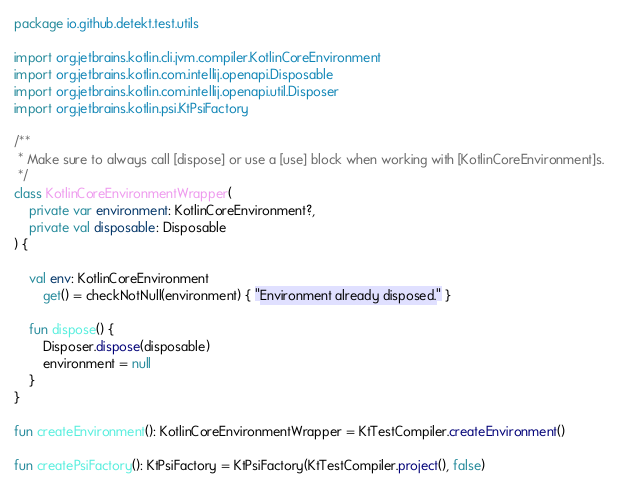Convert code to text. <code><loc_0><loc_0><loc_500><loc_500><_Kotlin_>package io.github.detekt.test.utils

import org.jetbrains.kotlin.cli.jvm.compiler.KotlinCoreEnvironment
import org.jetbrains.kotlin.com.intellij.openapi.Disposable
import org.jetbrains.kotlin.com.intellij.openapi.util.Disposer
import org.jetbrains.kotlin.psi.KtPsiFactory

/**
 * Make sure to always call [dispose] or use a [use] block when working with [KotlinCoreEnvironment]s.
 */
class KotlinCoreEnvironmentWrapper(
    private var environment: KotlinCoreEnvironment?,
    private val disposable: Disposable
) {

    val env: KotlinCoreEnvironment
        get() = checkNotNull(environment) { "Environment already disposed." }

    fun dispose() {
        Disposer.dispose(disposable)
        environment = null
    }
}

fun createEnvironment(): KotlinCoreEnvironmentWrapper = KtTestCompiler.createEnvironment()

fun createPsiFactory(): KtPsiFactory = KtPsiFactory(KtTestCompiler.project(), false)
</code> 